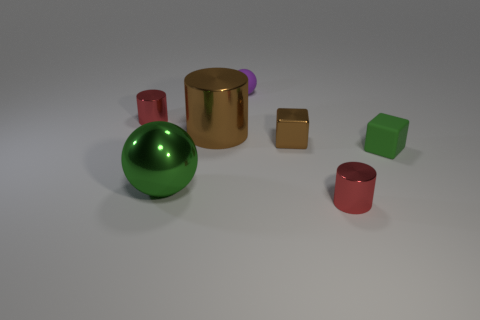Subtract all big brown metal cylinders. How many cylinders are left? 2 Add 1 purple things. How many objects exist? 8 Subtract all blue cubes. How many red cylinders are left? 2 Subtract all green spheres. How many spheres are left? 1 Subtract all large gray shiny cubes. Subtract all green rubber blocks. How many objects are left? 6 Add 6 tiny green objects. How many tiny green objects are left? 7 Add 5 tiny cubes. How many tiny cubes exist? 7 Subtract 0 red balls. How many objects are left? 7 Subtract all cylinders. How many objects are left? 4 Subtract all red balls. Subtract all gray blocks. How many balls are left? 2 